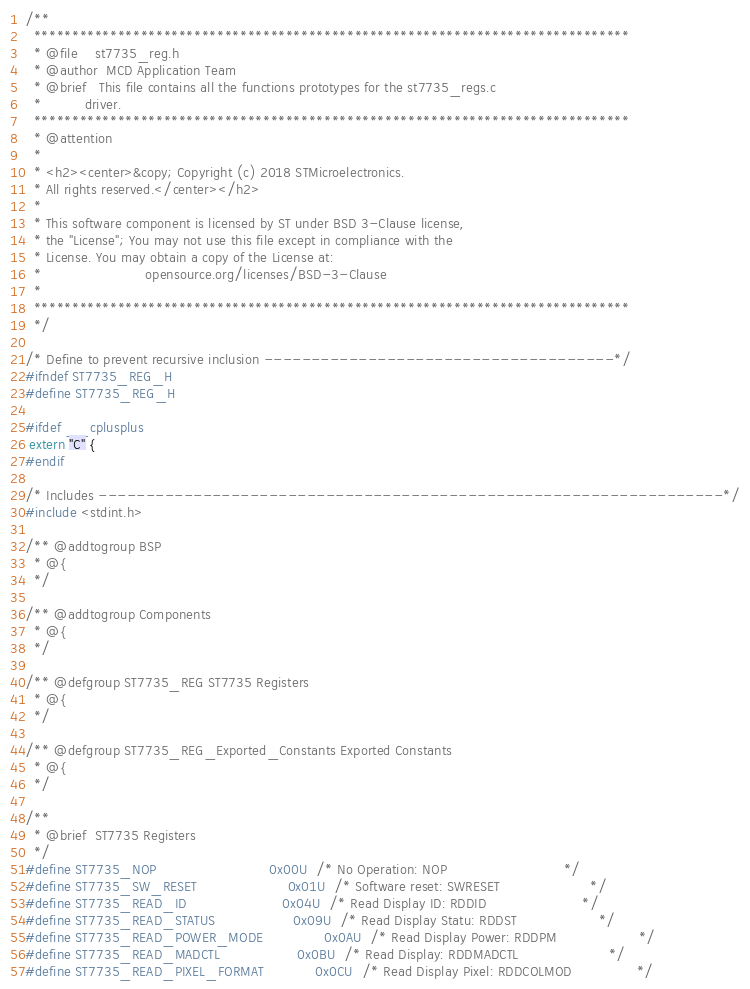Convert code to text. <code><loc_0><loc_0><loc_500><loc_500><_C_>/**
  ******************************************************************************
  * @file    st7735_reg.h
  * @author  MCD Application Team
  * @brief   This file contains all the functions prototypes for the st7735_regs.c
  *          driver.
  ******************************************************************************
  * @attention
  *
  * <h2><center>&copy; Copyright (c) 2018 STMicroelectronics.
  * All rights reserved.</center></h2>
  *
  * This software component is licensed by ST under BSD 3-Clause license,
  * the "License"; You may not use this file except in compliance with the
  * License. You may obtain a copy of the License at:
  *                        opensource.org/licenses/BSD-3-Clause
  *
  ******************************************************************************
  */

/* Define to prevent recursive inclusion -------------------------------------*/
#ifndef ST7735_REG_H
#define ST7735_REG_H

#ifdef __cplusplus
 extern "C" {
#endif 

/* Includes ------------------------------------------------------------------*/
#include <stdint.h>

/** @addtogroup BSP
  * @{
  */ 

/** @addtogroup Components
  * @{
  */ 
  
/** @defgroup ST7735_REG ST7735 Registers
  * @{
  */

/** @defgroup ST7735_REG_Exported_Constants Exported Constants
  * @{
  */
 
/** 
  * @brief  ST7735 Registers  
  */
#define ST7735_NOP                          0x00U  /* No Operation: NOP                           */
#define ST7735_SW_RESET                     0x01U  /* Software reset: SWRESET                     */
#define ST7735_READ_ID                      0x04U  /* Read Display ID: RDDID                      */
#define ST7735_READ_STATUS                  0x09U  /* Read Display Statu: RDDST                   */
#define ST7735_READ_POWER_MODE              0x0AU  /* Read Display Power: RDDPM                   */
#define ST7735_READ_MADCTL                  0x0BU  /* Read Display: RDDMADCTL                     */
#define ST7735_READ_PIXEL_FORMAT            0x0CU  /* Read Display Pixel: RDDCOLMOD               */  </code> 